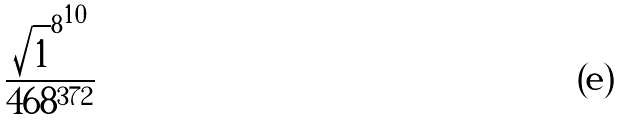Convert formula to latex. <formula><loc_0><loc_0><loc_500><loc_500>\frac { { \sqrt { 1 } ^ { 8 } } ^ { 1 0 } } { 4 6 8 ^ { 3 7 2 } }</formula> 